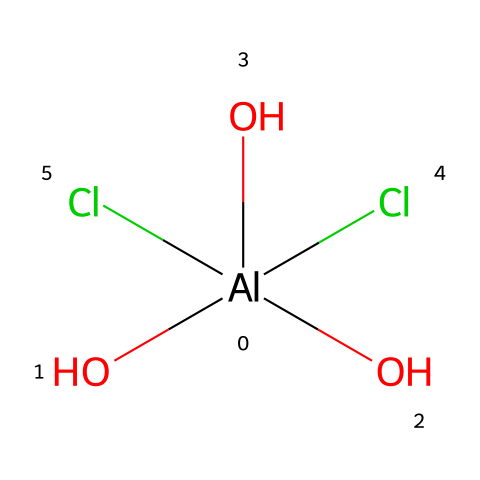What is the central metal in this compound? The chemical structure includes an aluminum atom that is bonded to other atoms, which identifies it as an organometallic compound.
Answer: aluminum How many chlorine atoms are present in this structure? The SMILES representation shows "Cl" appearing two times, indicating there are two chlorine atoms in the compound.
Answer: 2 What is the coordination number of aluminum in this compound? The aluminum atom is bonded to five oxygens and chlorines (three hydroxyl groups and two chlorines), so its coordination number is five.
Answer: 5 Which functional groups are identified in this organometallic structure? The chemical shows three hydroxyl groups (indicated by "O") and two chlorine groups. This means the functional groups present are hydroxyls and chlorines.
Answer: hydroxyl and chlorine How does the presence of chlorine affect the properties of this compound? Chlorine presence usually influences reactivity and solubility due to its electronegativity and size; in aluminum compounds, chlorines can increase solubility in polar solvents.
Answer: increases solubility What type of bonding is predominant in organometallics like this compound? Organometallic compounds primarily consist of covalent bonds between the metal (aluminum) and nonmetals (oxygen, chlorine) due to electron sharing.
Answer: covalent bonding 